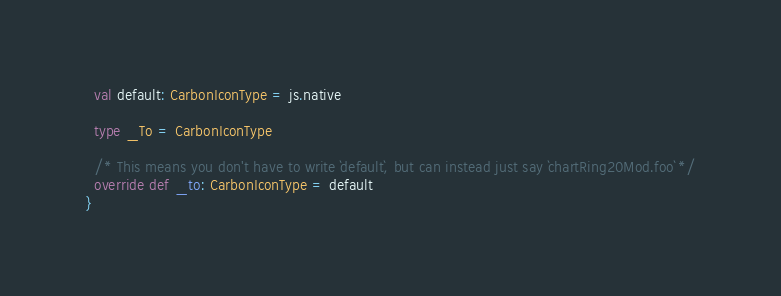<code> <loc_0><loc_0><loc_500><loc_500><_Scala_>  val default: CarbonIconType = js.native
  
  type _To = CarbonIconType
  
  /* This means you don't have to write `default`, but can instead just say `chartRing20Mod.foo` */
  override def _to: CarbonIconType = default
}
</code> 